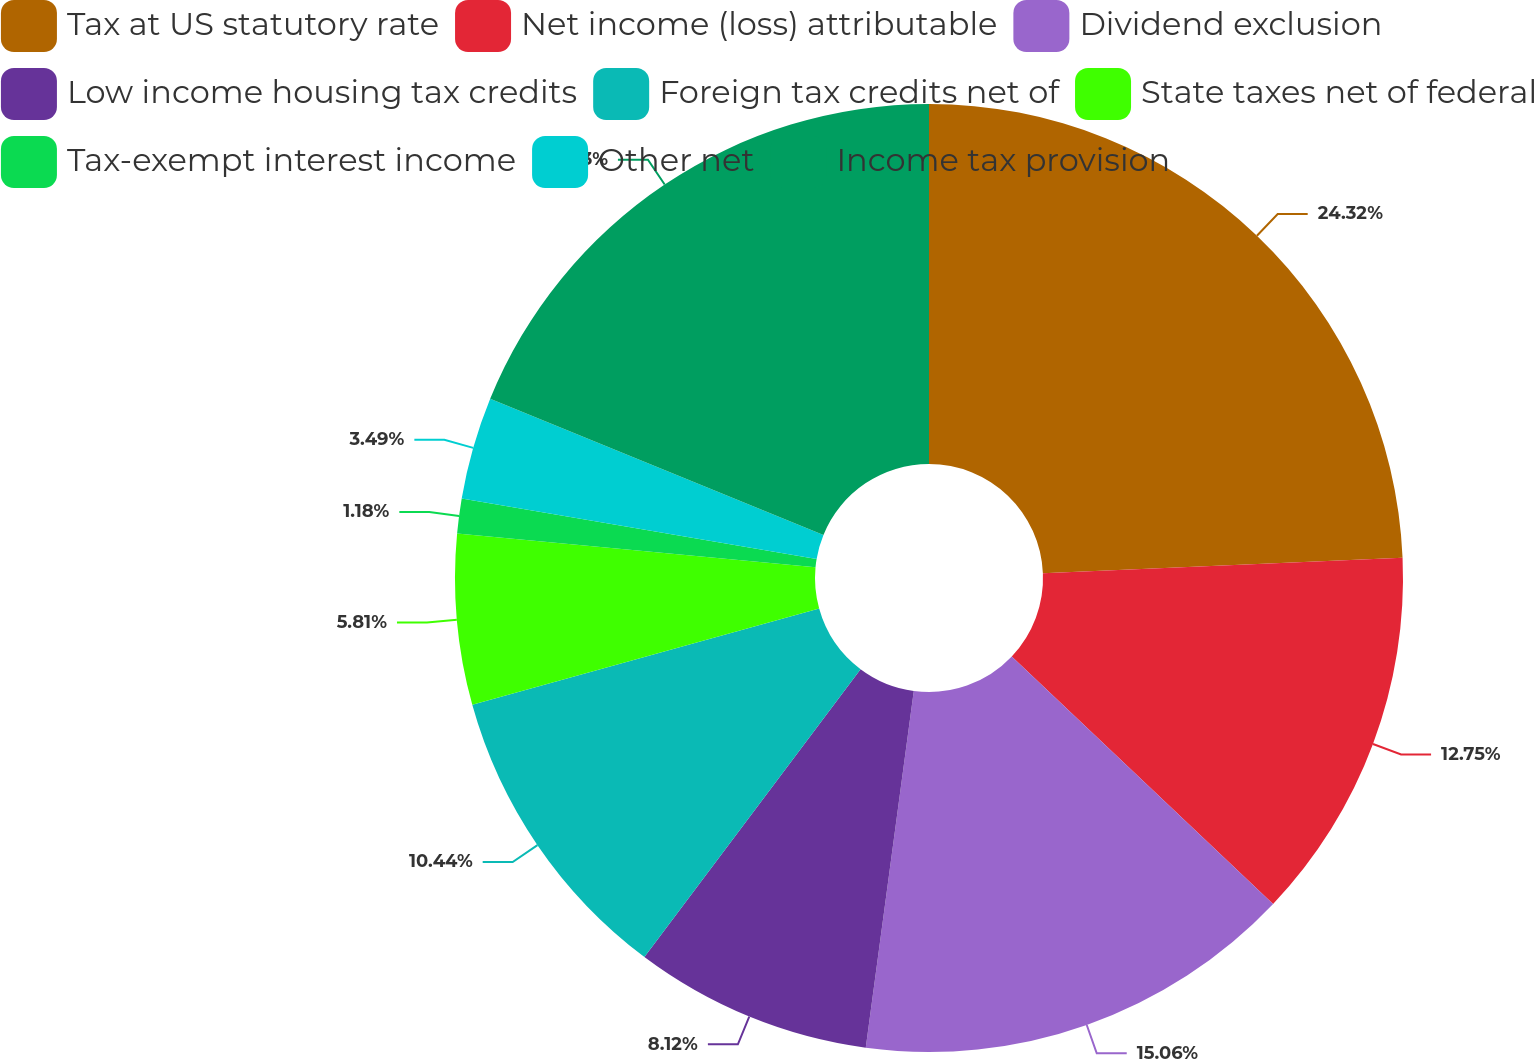Convert chart. <chart><loc_0><loc_0><loc_500><loc_500><pie_chart><fcel>Tax at US statutory rate<fcel>Net income (loss) attributable<fcel>Dividend exclusion<fcel>Low income housing tax credits<fcel>Foreign tax credits net of<fcel>State taxes net of federal<fcel>Tax-exempt interest income<fcel>Other net<fcel>Income tax provision<nl><fcel>24.32%<fcel>12.75%<fcel>15.06%<fcel>8.12%<fcel>10.44%<fcel>5.81%<fcel>1.18%<fcel>3.49%<fcel>18.83%<nl></chart> 